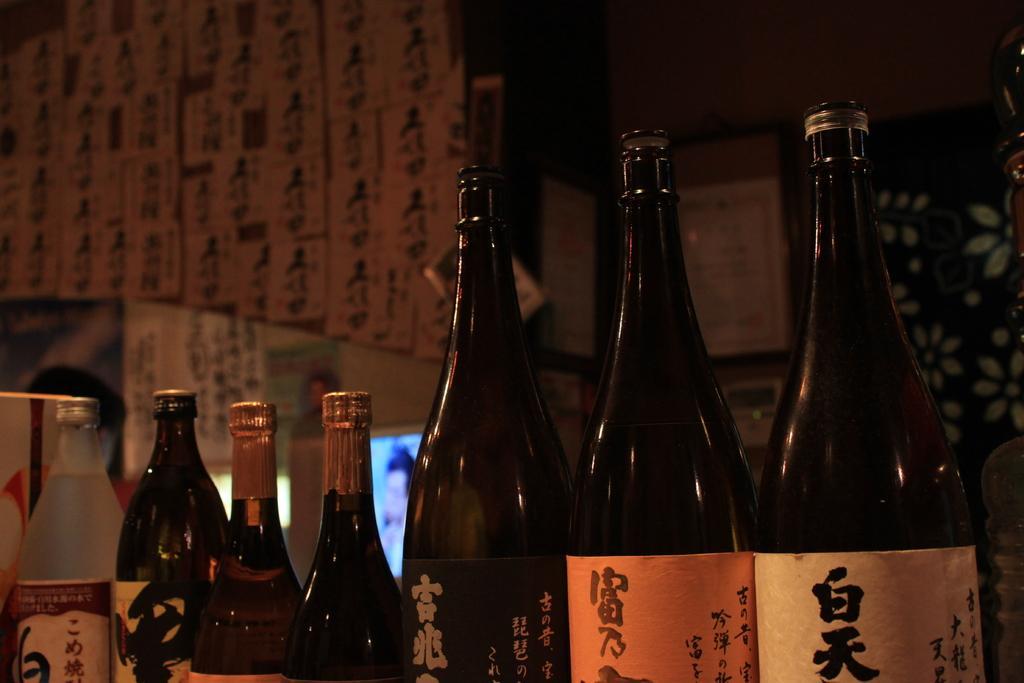Please provide a concise description of this image. This picture is of inside. In the foreground we can see many number of drink bottles in which four of them are sealed and three of them are open. In the background we can see the wall. 